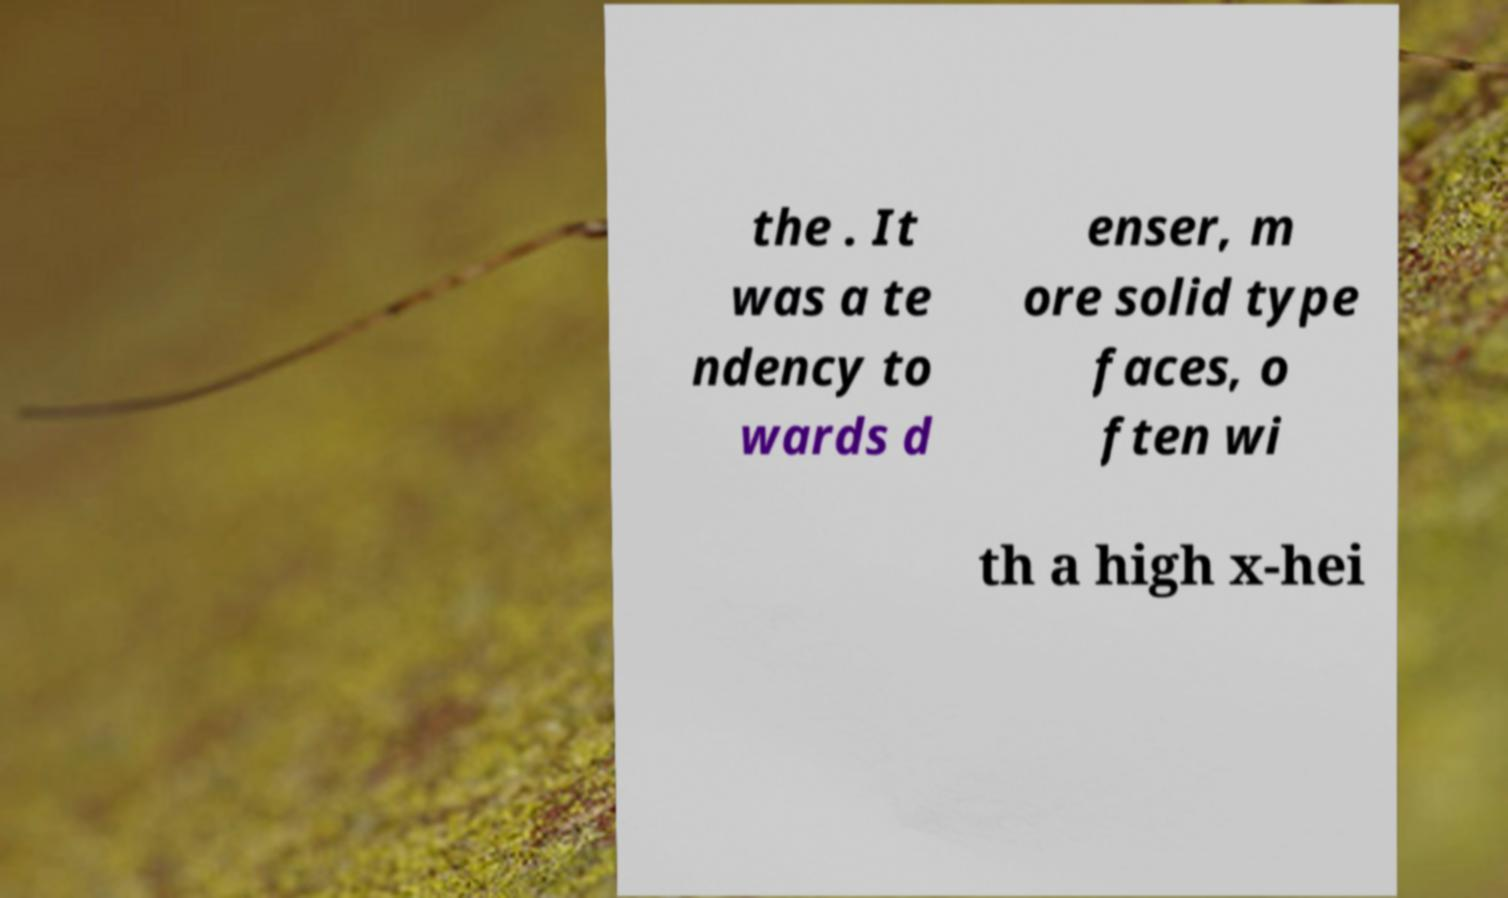Could you extract and type out the text from this image? the . It was a te ndency to wards d enser, m ore solid type faces, o ften wi th a high x-hei 